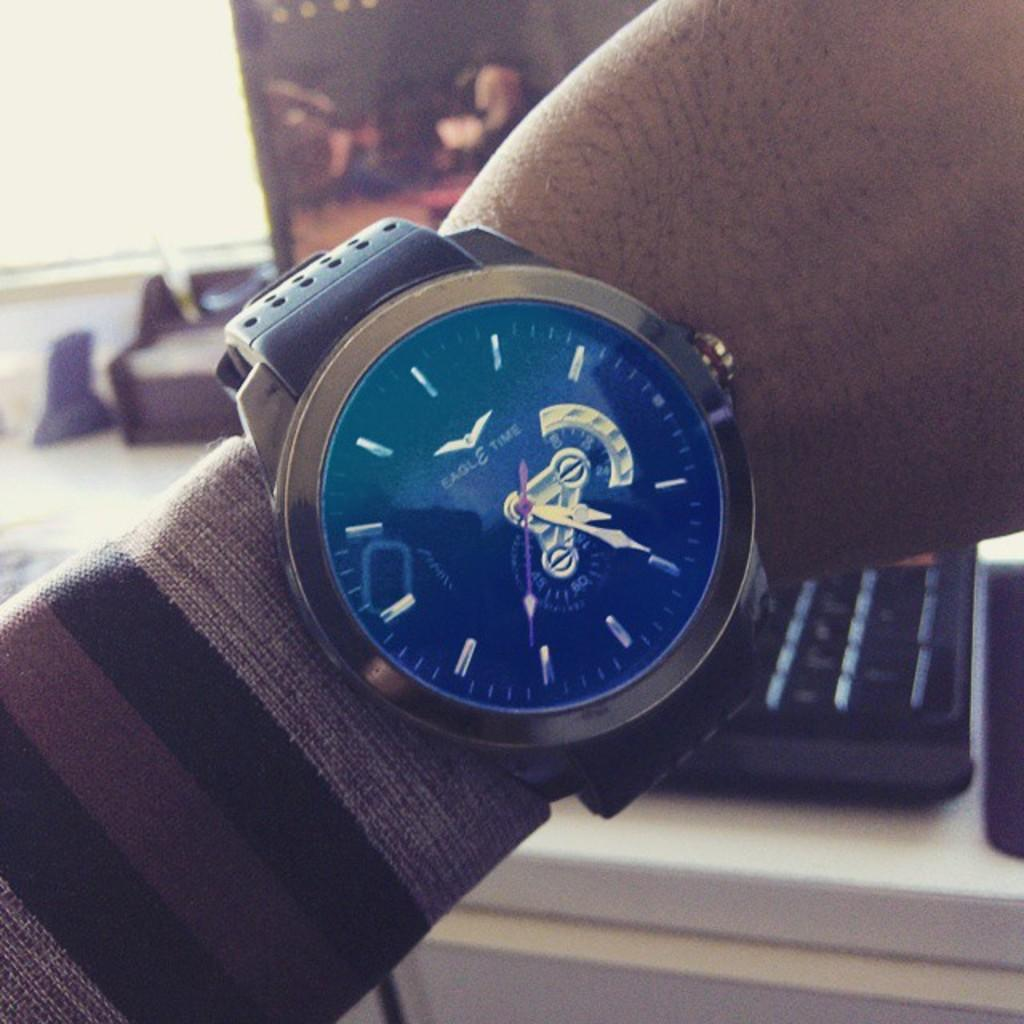<image>
Provide a brief description of the given image. Person wearing a blute and silver watch that says "Eagle Time" on it. 